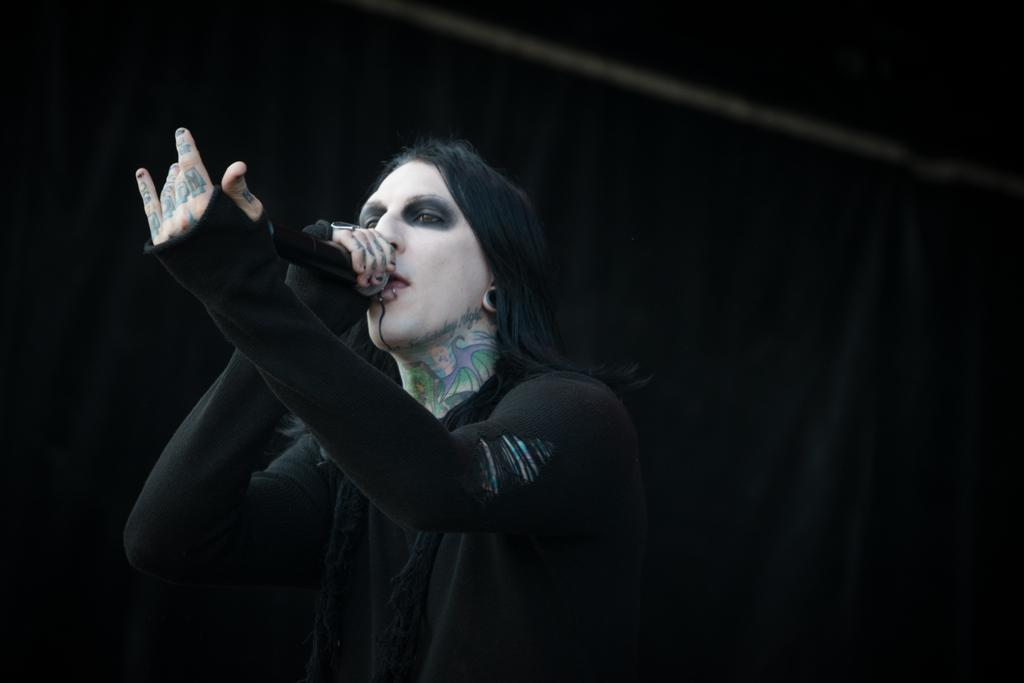What is the main subject of the image? There is a person in the image. What is the person holding in the image? The person is holding a mic. What is the person wearing in the image? The person is wearing a black dress. What color is the background of the image? The background of the image is black. What type of pot can be seen in the person's territory in the image? There is no pot or territory present in the image; it features a person holding a mic and wearing a black dress against a black background. 